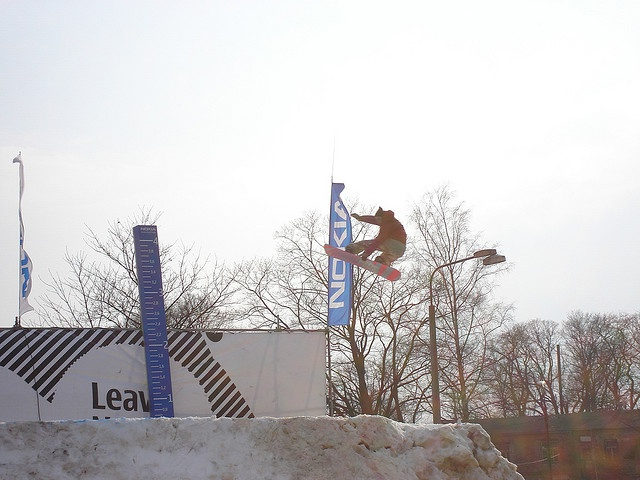Describe the objects in this image and their specific colors. I can see people in lavender, gray, brown, and darkgray tones and snowboard in lavender, gray, and darkgray tones in this image. 